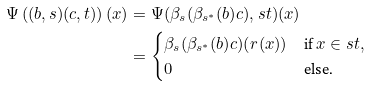Convert formula to latex. <formula><loc_0><loc_0><loc_500><loc_500>\Psi \left ( ( b , s ) ( c , t ) \right ) ( x ) & = \Psi ( \beta _ { s } ( \beta _ { s ^ { * } } ( b ) c ) , s t ) ( x ) \\ & = \begin{cases} \beta _ { s } ( \beta _ { s ^ { * } } ( b ) c ) ( r ( x ) ) & \text {if } x \in s t , \\ 0 & \text {else.} \end{cases}</formula> 